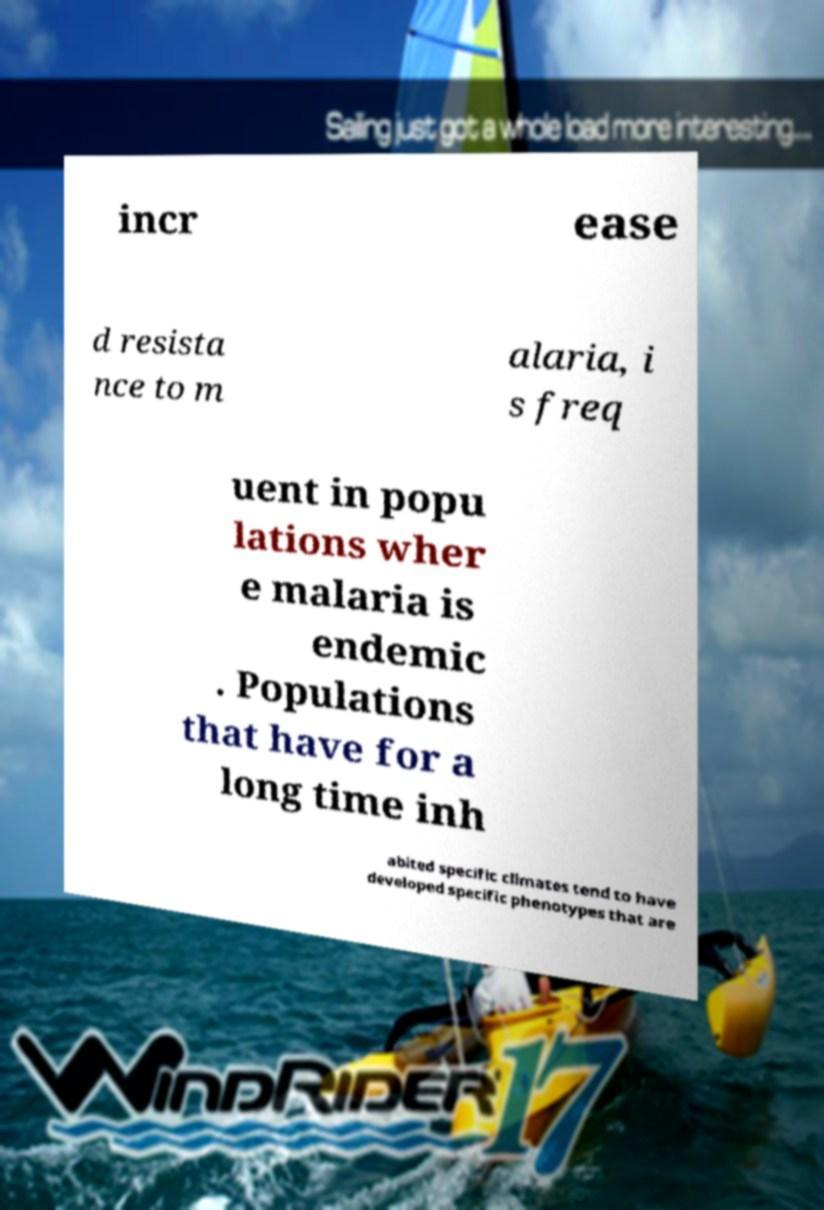Please identify and transcribe the text found in this image. incr ease d resista nce to m alaria, i s freq uent in popu lations wher e malaria is endemic . Populations that have for a long time inh abited specific climates tend to have developed specific phenotypes that are 